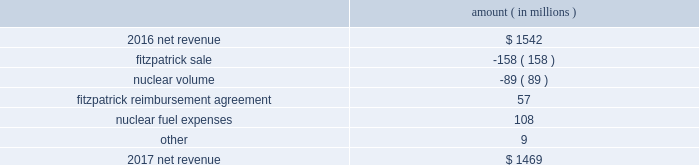The regulatory credit resulting from reduction of the federal corporate income tax rate variance is due to the reduction of the vidalia purchased power agreement regulatory liability by $ 30.5 million and the reduction of the louisiana act 55 financing savings obligation regulatory liabilities by $ 25 million as a result of the enactment of the tax cuts and jobs act , in december 2017 , which lowered the federal corporate income tax rate from 35% ( 35 % ) to 21% ( 21 % ) .
The effects of the tax cuts and jobs act are discussed further in note 3 to the financial statements .
The grand gulf recovery variance is primarily due to increased recovery of higher operating costs .
The louisiana act 55 financing savings obligation variance results from a regulatory charge in 2016 for tax savings to be shared with customers per an agreement approved by the lpsc .
The tax savings resulted from the 2010-2011 irs audit settlement on the treatment of the louisiana act 55 financing of storm costs for hurricane gustav and hurricane ike .
See note 3 to the financial statements for additional discussion of the settlement and benefit sharing .
The volume/weather variance is primarily due to the effect of less favorable weather on residential and commercial sales , partially offset by an increase in industrial usage .
The increase in industrial usage is primarily due to new customers in the primary metals industry and expansion projects and an increase in demand for existing customers in the chlor-alkali industry .
Entergy wholesale commodities following is an analysis of the change in net revenue comparing 2017 to 2016 .
Amount ( in millions ) .
As shown in the table above , net revenue for entergy wholesale commodities decreased by approximately $ 73 million in 2017 primarily due to the absence of net revenue from the fitzpatrick plant after it was sold to exelon in march 2017 and lower volume in the entergy wholesale commodities nuclear fleet resulting from more outage days in 2017 as compared to 2016 .
The decrease was partially offset by an increase resulting from the reimbursement agreement with exelon pursuant to which exelon reimbursed entergy for specified out-of-pocket costs associated with preparing for the refueling and operation of fitzpatrick that otherwise would have been avoided had entergy shut down fitzpatrick in january 2017 and a decrease in nuclear fuel expenses primarily related to the impairments of the indian point 2 , indian point 3 , and palisades plants and related assets .
Revenues received from exelon in 2017 under the reimbursement agreement are offset by other operation and maintenance expenses and taxes other than income taxes and had no effect on net income .
See note 14 to the financial statements for discussion of the sale of fitzpatrick , the reimbursement agreement with exelon , and the impairments and related charges .
Entergy corporation and subsidiaries management 2019s financial discussion and analysis .
What is the percent change in net revenue from 2016 to 2017? 
Computations: ((1542 - 1469) / 1469)
Answer: 0.04969. 